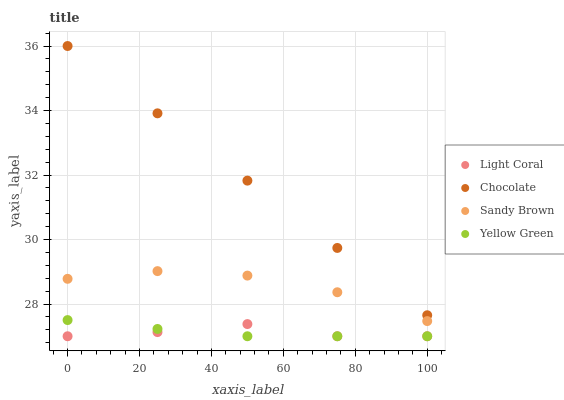Does Yellow Green have the minimum area under the curve?
Answer yes or no. Yes. Does Chocolate have the maximum area under the curve?
Answer yes or no. Yes. Does Sandy Brown have the minimum area under the curve?
Answer yes or no. No. Does Sandy Brown have the maximum area under the curve?
Answer yes or no. No. Is Chocolate the smoothest?
Answer yes or no. Yes. Is Sandy Brown the roughest?
Answer yes or no. Yes. Is Yellow Green the smoothest?
Answer yes or no. No. Is Yellow Green the roughest?
Answer yes or no. No. Does Light Coral have the lowest value?
Answer yes or no. Yes. Does Sandy Brown have the lowest value?
Answer yes or no. No. Does Chocolate have the highest value?
Answer yes or no. Yes. Does Sandy Brown have the highest value?
Answer yes or no. No. Is Light Coral less than Sandy Brown?
Answer yes or no. Yes. Is Chocolate greater than Yellow Green?
Answer yes or no. Yes. Does Light Coral intersect Yellow Green?
Answer yes or no. Yes. Is Light Coral less than Yellow Green?
Answer yes or no. No. Is Light Coral greater than Yellow Green?
Answer yes or no. No. Does Light Coral intersect Sandy Brown?
Answer yes or no. No. 